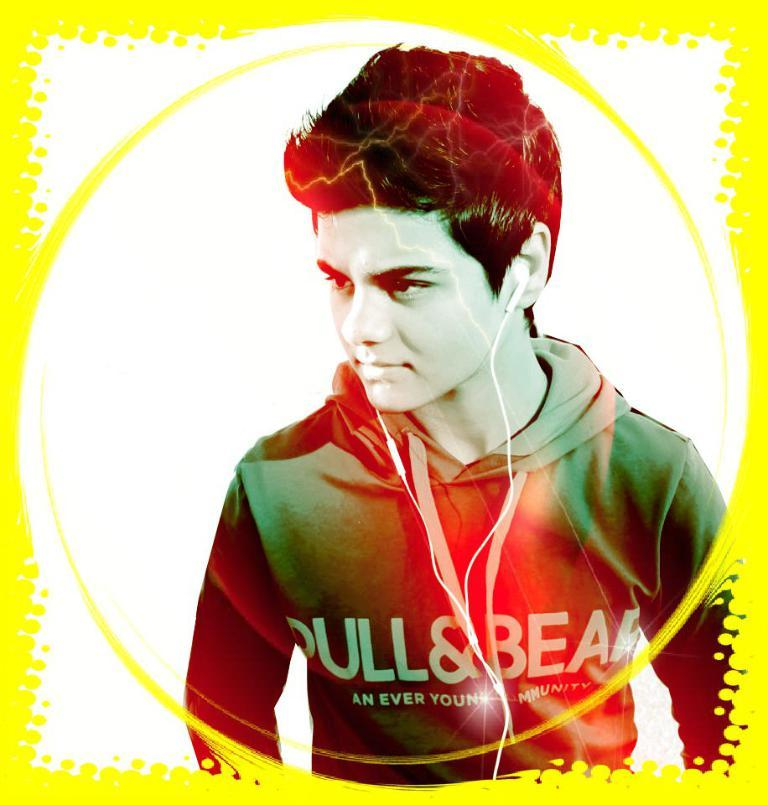What is the main subject of the image? The main subject of the image is a man. What can be seen on the man's head in the image? The man is wearing a headset in the image. How many cows can be seen in the image? There are no cows present in the image. What sound does the bell make in the image? There is no bell present in the image. 